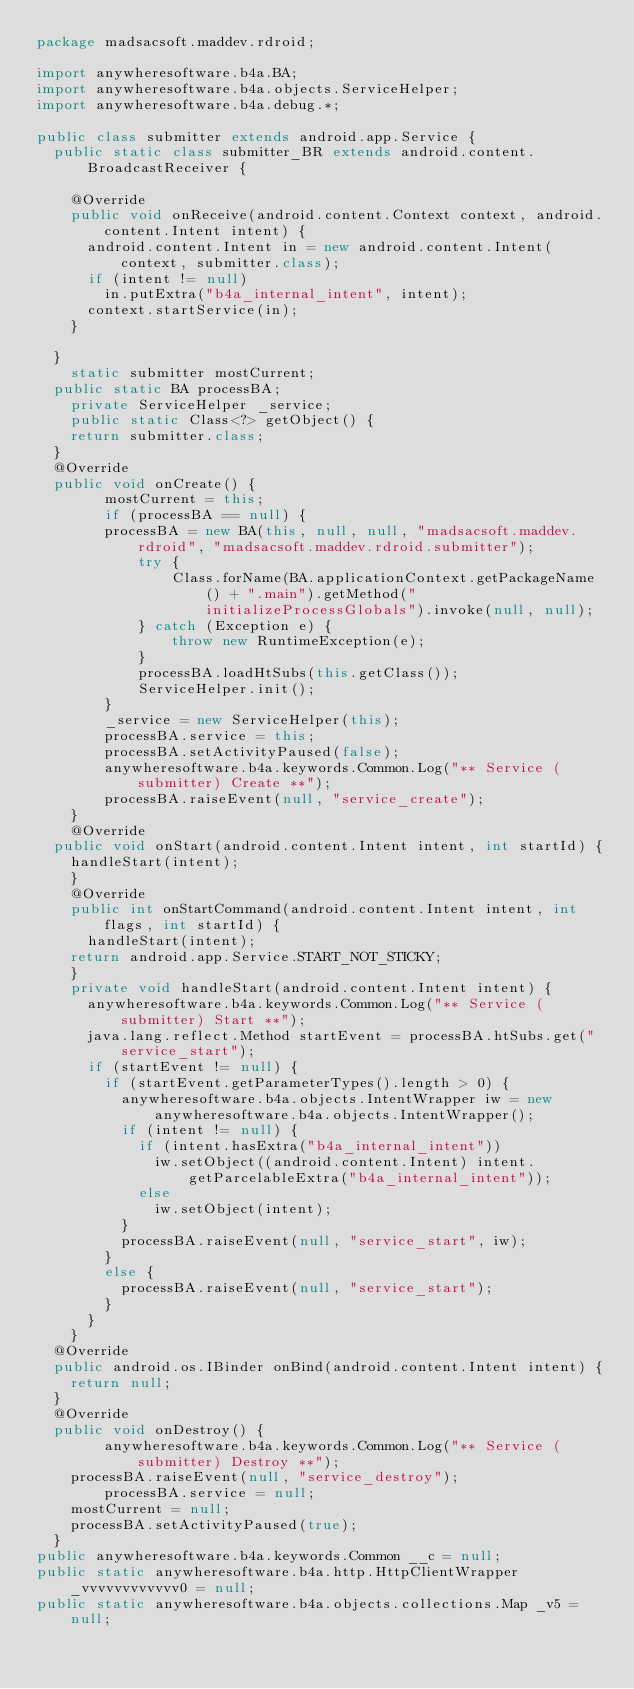Convert code to text. <code><loc_0><loc_0><loc_500><loc_500><_Java_>package madsacsoft.maddev.rdroid;

import anywheresoftware.b4a.BA;
import anywheresoftware.b4a.objects.ServiceHelper;
import anywheresoftware.b4a.debug.*;

public class submitter extends android.app.Service {
	public static class submitter_BR extends android.content.BroadcastReceiver {

		@Override
		public void onReceive(android.content.Context context, android.content.Intent intent) {
			android.content.Intent in = new android.content.Intent(context, submitter.class);
			if (intent != null)
				in.putExtra("b4a_internal_intent", intent);
			context.startService(in);
		}

	}
    static submitter mostCurrent;
	public static BA processBA;
    private ServiceHelper _service;
    public static Class<?> getObject() {
		return submitter.class;
	}
	@Override
	public void onCreate() {
        mostCurrent = this;
        if (processBA == null) {
		    processBA = new BA(this, null, null, "madsacsoft.maddev.rdroid", "madsacsoft.maddev.rdroid.submitter");
            try {
                Class.forName(BA.applicationContext.getPackageName() + ".main").getMethod("initializeProcessGlobals").invoke(null, null);
            } catch (Exception e) {
                throw new RuntimeException(e);
            }
            processBA.loadHtSubs(this.getClass());
            ServiceHelper.init();
        }
        _service = new ServiceHelper(this);
        processBA.service = this;
        processBA.setActivityPaused(false);
        anywheresoftware.b4a.keywords.Common.Log("** Service (submitter) Create **");
        processBA.raiseEvent(null, "service_create");
    }
		@Override
	public void onStart(android.content.Intent intent, int startId) {
		handleStart(intent);
    }
    @Override
    public int onStartCommand(android.content.Intent intent, int flags, int startId) {
    	handleStart(intent);
		return android.app.Service.START_NOT_STICKY;
    }
    private void handleStart(android.content.Intent intent) {
    	anywheresoftware.b4a.keywords.Common.Log("** Service (submitter) Start **");
    	java.lang.reflect.Method startEvent = processBA.htSubs.get("service_start");
    	if (startEvent != null) {
    		if (startEvent.getParameterTypes().length > 0) {
    			anywheresoftware.b4a.objects.IntentWrapper iw = new anywheresoftware.b4a.objects.IntentWrapper();
    			if (intent != null) {
    				if (intent.hasExtra("b4a_internal_intent"))
    					iw.setObject((android.content.Intent) intent.getParcelableExtra("b4a_internal_intent"));
    				else
    					iw.setObject(intent);
    			}
    			processBA.raiseEvent(null, "service_start", iw);
    		}
    		else {
    			processBA.raiseEvent(null, "service_start");
    		}
    	}
    }
	@Override
	public android.os.IBinder onBind(android.content.Intent intent) {
		return null;
	}
	@Override
	public void onDestroy() {
        anywheresoftware.b4a.keywords.Common.Log("** Service (submitter) Destroy **");
		processBA.raiseEvent(null, "service_destroy");
        processBA.service = null;
		mostCurrent = null;
		processBA.setActivityPaused(true);
	}
public anywheresoftware.b4a.keywords.Common __c = null;
public static anywheresoftware.b4a.http.HttpClientWrapper _vvvvvvvvvvvv0 = null;
public static anywheresoftware.b4a.objects.collections.Map _v5 = null;</code> 